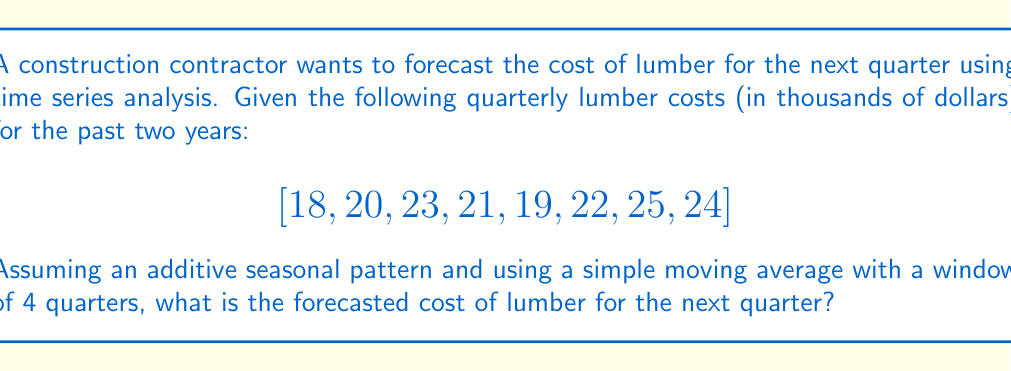Show me your answer to this math problem. 1. Identify the seasonal component:
   Calculate the average for each season across the two years:
   Q1: $(18 + 19) / 2 = 18.5$
   Q2: $(20 + 22) / 2 = 21$
   Q3: $(23 + 25) / 2 = 24$
   Q4: $(21 + 24) / 2 = 22.5$

2. Calculate the overall average:
   $\text{Overall average} = (18.5 + 21 + 24 + 22.5) / 4 = 21.5$

3. Compute the seasonal indices:
   Q1: $18.5 - 21.5 = -3$
   Q2: $21 - 21.5 = -0.5$
   Q3: $24 - 21.5 = 2.5$
   Q4: $22.5 - 21.5 = 1$

4. Calculate the 4-quarter moving average:
   $MA_1 = (18 + 20 + 23 + 21) / 4 = 20.5$
   $MA_2 = (20 + 23 + 21 + 19) / 4 = 20.75$
   $MA_3 = (23 + 21 + 19 + 22) / 4 = 21.25$
   $MA_4 = (21 + 19 + 22 + 25) / 4 = 21.75$
   $MA_5 = (19 + 22 + 25 + 24) / 4 = 22.5$

5. The last moving average (22.5) represents the trend-cycle component for the current quarter (Q4).

6. To forecast the next quarter (Q1), add the seasonal index for Q1 to the trend-cycle component:
   $\text{Forecast} = 22.5 + (-3) = 19.5$

Therefore, the forecasted cost of lumber for the next quarter is $19,500.
Answer: $19,500 